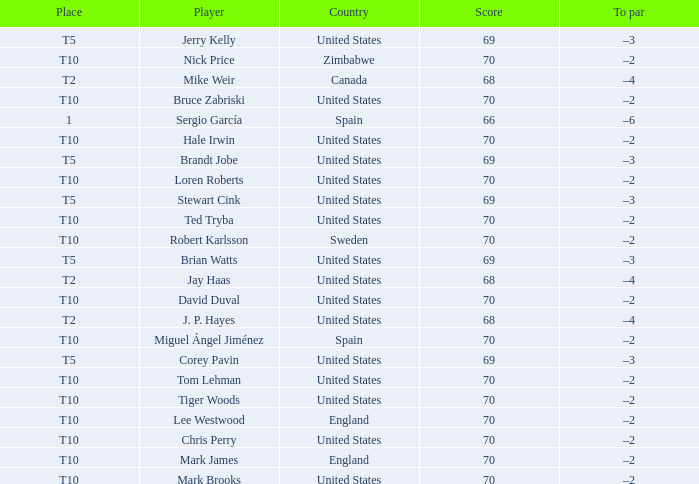What was the highest score of t5 place finisher brandt jobe? 69.0. Parse the full table. {'header': ['Place', 'Player', 'Country', 'Score', 'To par'], 'rows': [['T5', 'Jerry Kelly', 'United States', '69', '–3'], ['T10', 'Nick Price', 'Zimbabwe', '70', '–2'], ['T2', 'Mike Weir', 'Canada', '68', '–4'], ['T10', 'Bruce Zabriski', 'United States', '70', '–2'], ['1', 'Sergio García', 'Spain', '66', '–6'], ['T10', 'Hale Irwin', 'United States', '70', '–2'], ['T5', 'Brandt Jobe', 'United States', '69', '–3'], ['T10', 'Loren Roberts', 'United States', '70', '–2'], ['T5', 'Stewart Cink', 'United States', '69', '–3'], ['T10', 'Ted Tryba', 'United States', '70', '–2'], ['T10', 'Robert Karlsson', 'Sweden', '70', '–2'], ['T5', 'Brian Watts', 'United States', '69', '–3'], ['T2', 'Jay Haas', 'United States', '68', '–4'], ['T10', 'David Duval', 'United States', '70', '–2'], ['T2', 'J. P. Hayes', 'United States', '68', '–4'], ['T10', 'Miguel Ángel Jiménez', 'Spain', '70', '–2'], ['T5', 'Corey Pavin', 'United States', '69', '–3'], ['T10', 'Tom Lehman', 'United States', '70', '–2'], ['T10', 'Tiger Woods', 'United States', '70', '–2'], ['T10', 'Lee Westwood', 'England', '70', '–2'], ['T10', 'Chris Perry', 'United States', '70', '–2'], ['T10', 'Mark James', 'England', '70', '–2'], ['T10', 'Mark Brooks', 'United States', '70', '–2']]} 